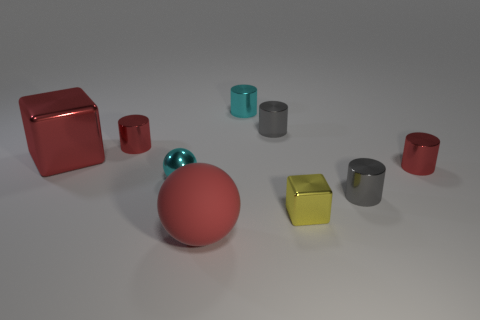Does the small metallic cylinder that is on the left side of the big red ball have the same color as the matte sphere?
Offer a terse response. Yes. What size is the cyan metal object that is the same shape as the matte object?
Provide a short and direct response. Small. Is the color of the big shiny thing the same as the big rubber ball?
Offer a very short reply. Yes. The cylinder that is the same color as the metal ball is what size?
Keep it short and to the point. Small. There is a red cube that is to the left of the small cyan metallic cylinder; what material is it?
Offer a terse response. Metal. What is the material of the red ball?
Offer a very short reply. Rubber. Do the cyan object that is right of the matte ball and the red cube have the same material?
Ensure brevity in your answer.  Yes. Are there fewer big rubber things that are in front of the metallic sphere than small yellow metallic cubes?
Your answer should be compact. No. What is the color of the metal thing that is the same size as the red rubber thing?
Make the answer very short. Red. How many other gray metallic things are the same shape as the big metal thing?
Provide a succinct answer. 0. 